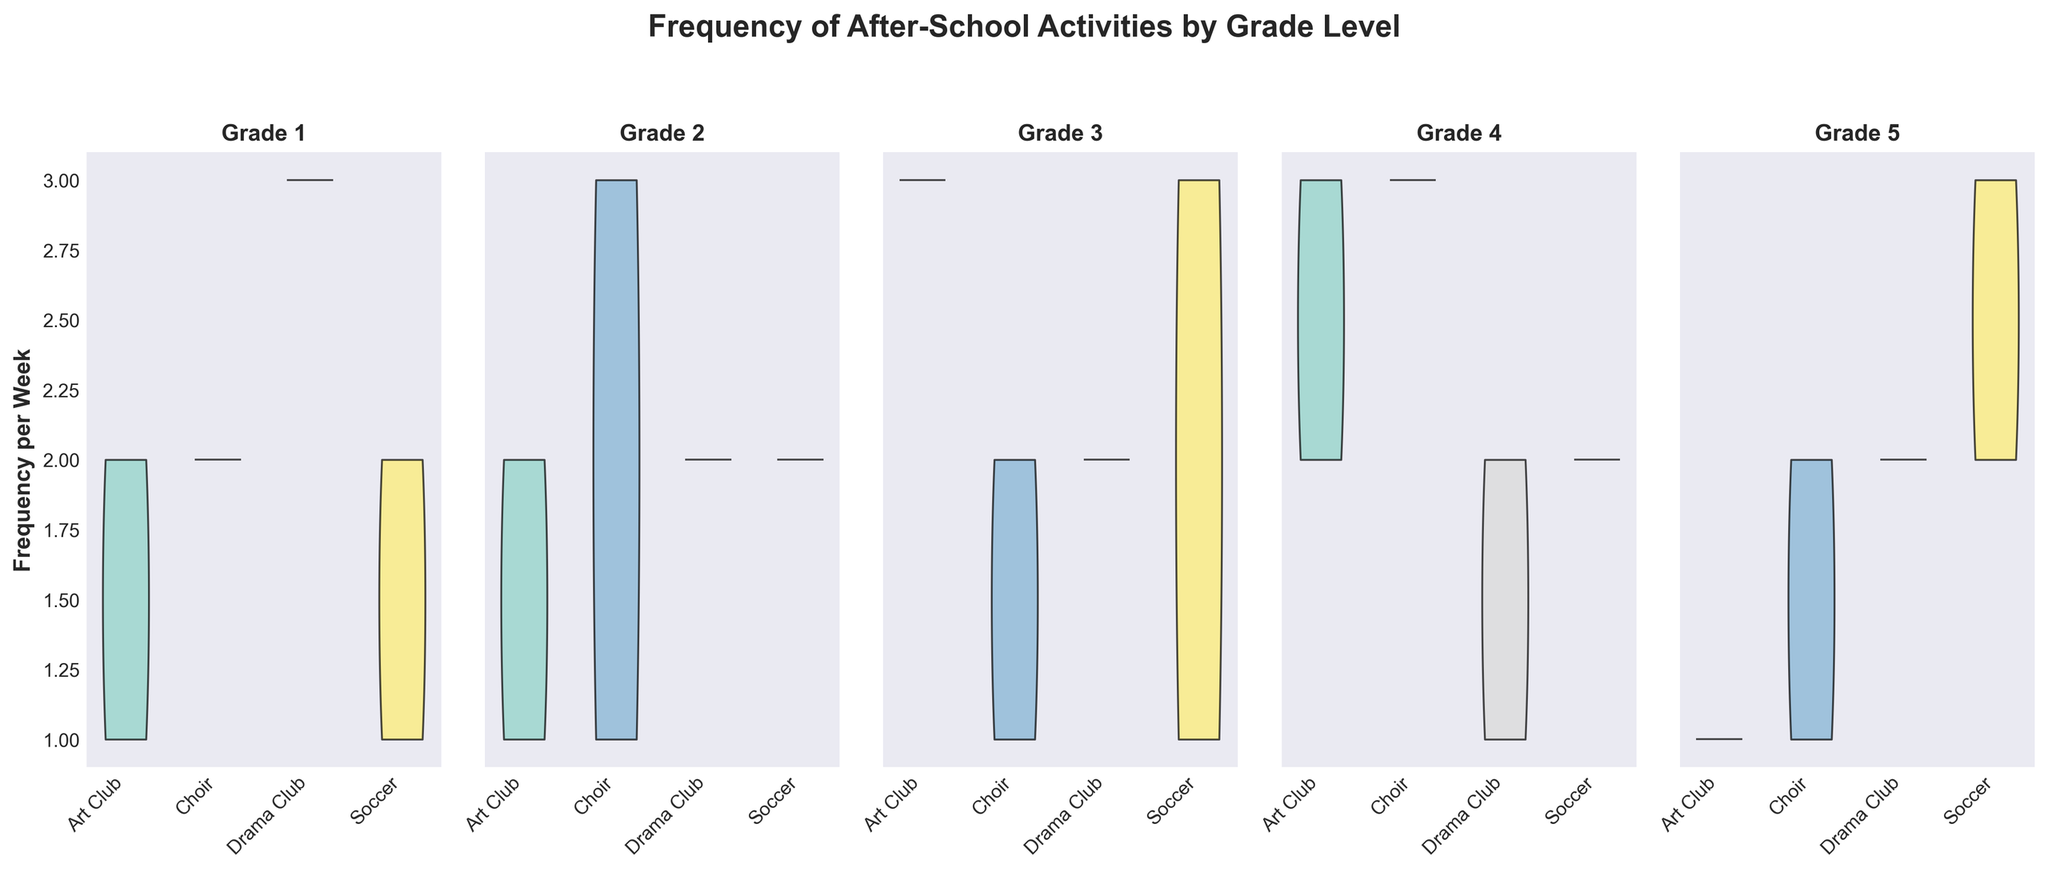What is the title of the figure? The title of the figure is usually located at the top, in this case, it reads "Frequency of After-School Activities by Grade Level".
Answer: Frequency of After-School Activities by Grade Level What are the 4 extracurricular activities shown in the figure? The labels on the x-axis typically list the extracurricular activities which in this figure are Art Club, Choir, Drama Club, and Soccer.
Answer: Art Club, Choir, Drama Club, Soccer How many grade levels are compared in the figure? Each subplot represents a grade level, and there are 5 subplots labeled from Grade 1 to Grade 5.
Answer: 5 Which grade level has the highest range of frequency for Art Club? By visually comparing the range of the violin plots for Art Club across all grades, the plot with the widest span on the y-axis indicates the highest range. Grade 3 shows the highest range for Art Club.
Answer: Grade 3 In which grade level does Drama Club have the lowest median frequency per week? The width of the violin plots at the midpoint is the thinnest for Grade 1, indicating the lowest median frequency for Drama Club.
Answer: Grade 1 What can you say about the consistency of Soccer participation frequency across all grade levels? Observing the violin plots for Soccer from Grade 1 to Grade 5 shows varying widths and heights, indicating inconsistent participation frequencies across grade levels. The participation is more consistent in some grades like Grade 5, which shows a more uniform shape.
Answer: Inconsistent Which activity appears to be most popular in Grade 4? By examining the density and spread of each activity's plot in Grade 4, Art Club and Drama Club show higher density around higher frequencies, indicating popularity. Art Club has the most dense plot, suggesting it's the most popular.
Answer: Art Club Compare the frequency per week of Choir between Grade 2 and Grade 5. Which grade has a higher median frequency for Choir? By observing the symmetry and width of the violin plots for Choir in both grades, Grade 2 shows a broader distribution extending higher, indicating a higher median frequency compared to Grade 5.
Answer: Grade 2 Does any grade level show a clear preference for one extracurricular activity over others? We look for a violin plot that stands out for any grade level by having a much larger distribution and denser shape. Grade 5 shows a strong preference with a broader and denser plot for Soccer compared to other activities.
Answer: Grade 5 How does the frequency of participation in Art Club change across grade levels? By briefly reviewing each subplot for Art Club, we notice that the distribution changes in width and height subtly from Grade 1 through Grade 5. It increases slightly in higher grades with a broader variation in Grades 3 and 4.
Answer: Increases slightly across higher grades 